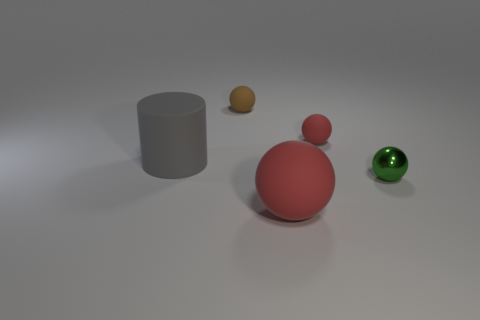Add 5 red matte things. How many objects exist? 10 Subtract all balls. How many objects are left? 1 Add 1 matte balls. How many matte balls exist? 4 Subtract 0 cyan cubes. How many objects are left? 5 Subtract all small yellow objects. Subtract all red spheres. How many objects are left? 3 Add 4 red objects. How many red objects are left? 6 